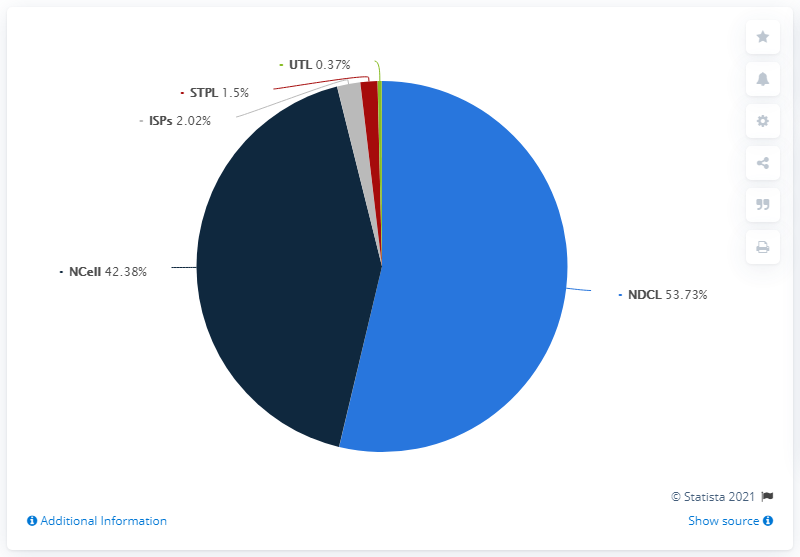Point out several critical features in this image. The smallest value represented in the pie chart is 0.37. 